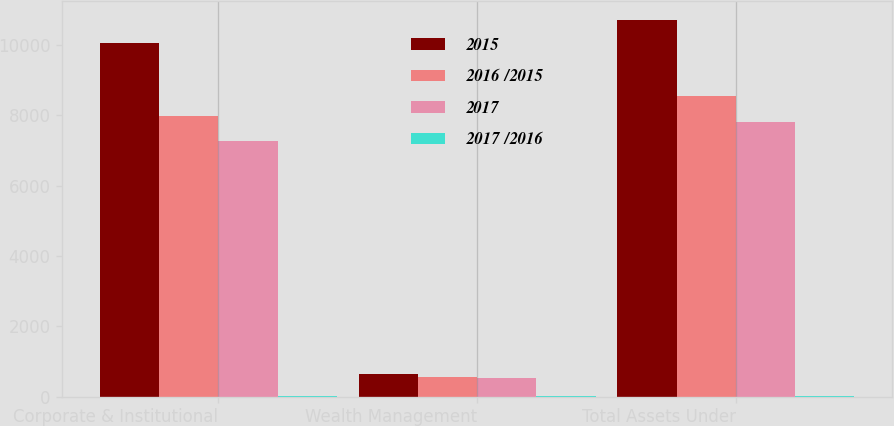<chart> <loc_0><loc_0><loc_500><loc_500><stacked_bar_chart><ecel><fcel>Corporate & Institutional<fcel>Wealth Management<fcel>Total Assets Under<nl><fcel>2015<fcel>10066.8<fcel>655.8<fcel>10722.6<nl><fcel>2016 /2015<fcel>7987<fcel>554.3<fcel>8541.3<nl><fcel>2017<fcel>7279.7<fcel>517.3<fcel>7797<nl><fcel>2017 /2016<fcel>26<fcel>18<fcel>26<nl></chart> 